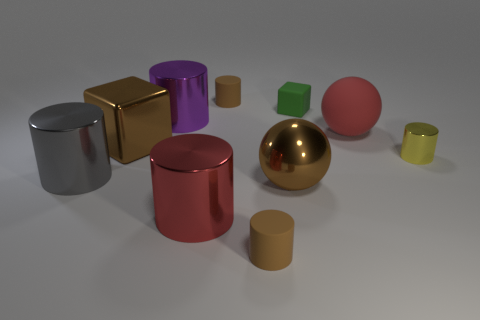Can you describe the differences in texture among the objects? Certainly! Most of the objects have a shiny, reflective texture suggesting a metallic material, particularly the gold, silver, and red cylinders. In contrast, the green cube and the smaller, less reflective cylinders have a matte texture, indicating a possibly different material, like plastic or a non-glossy metal. Which object stands out the most in the image and why? The gold sphere stands out the most due to its vibrant color and highly reflective surface, making it catch light and draw attention amidst the other objects. 